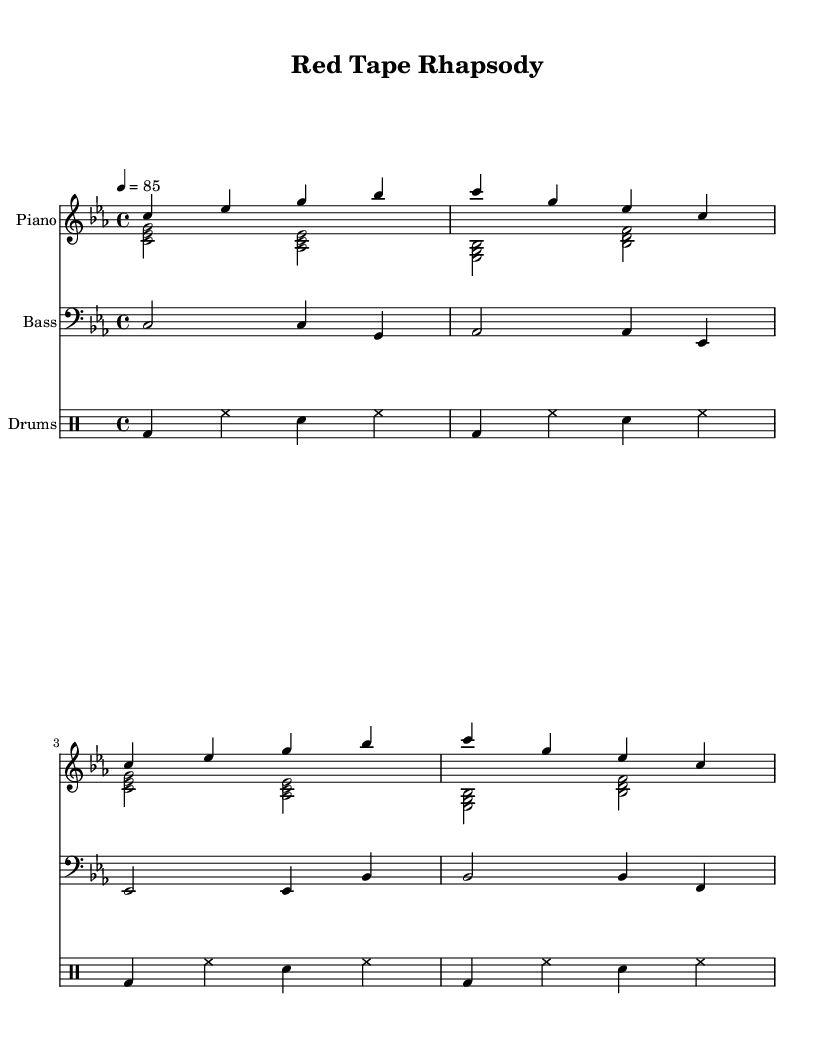What is the key signature of this music? The key signature indicates C minor, which has three flats (B flat, E flat, and A flat). You can identify the key signature by looking at the left side of the staff where the flats are placed.
Answer: C minor What is the time signature of this piece? The time signature is found at the beginning of the staff, which indicates how many beats are in each measure and what note value gets one beat. Here, the time signature is 4/4, meaning there are four beats per measure and the quarter note gets one beat.
Answer: 4/4 What is the tempo marking for this piece? The tempo marking is usually indicated below the staff, showing how fast the piece should be played. In this sheet music, the marking is "4 = 85," meaning a quarter note gets 85 beats per minute.
Answer: 85 How many measures are present in the right-hand piano part? To find the number of measures, count the groups of bars (vertical lines) in the right-hand piano part. There are four measures in that section of the music.
Answer: 4 What type of accompaniment is used in the left-hand piano part? The left-hand piano part features a harmonic structure mainly consisting of triads or chords, which supports the melody played in the right hand. By looking at the notes played simultaneously, we determine it is chordal accompaniment.
Answer: Chordal What is the function of the bass part in this arrangement? The bass part typically provides the fundamental bass notes and supports the harmony in the composition. By analyzing the note choices and rhythm in the bass, we see it complements the harmonic structure established by the piano.
Answer: Support harmony What rhythmic pattern is used in the drum part? The rhythm for the drums is told through the specific placements of bass drum, hi-hat, and snare drum throughout the measures. Analyzing these, we see it follows a consistent pattern of bass and hi-hat with snare accents.
Answer: Consistent pattern 